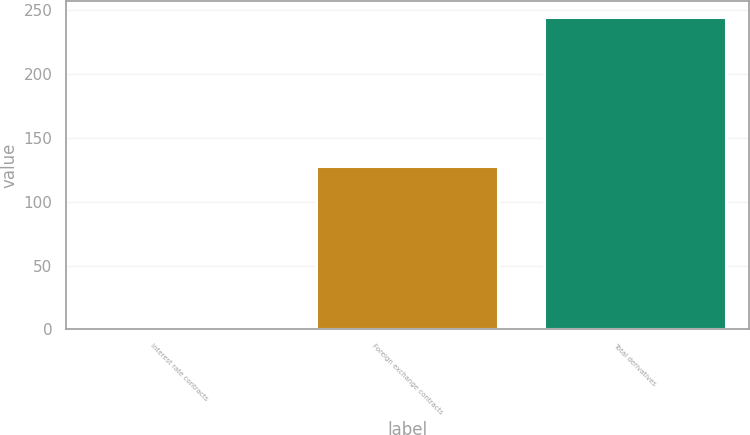Convert chart to OTSL. <chart><loc_0><loc_0><loc_500><loc_500><bar_chart><fcel>Interest rate contracts<fcel>Foreign exchange contracts<fcel>Total derivatives<nl><fcel>3<fcel>128<fcel>245<nl></chart> 